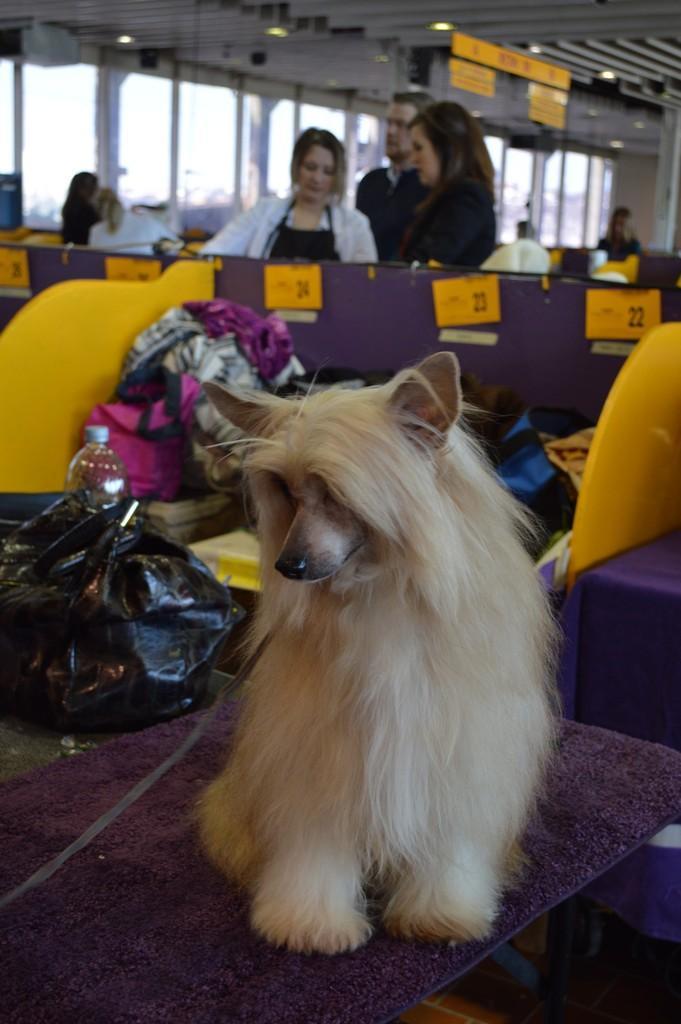Please provide a concise description of this image. In this picture I can see a dog, bag and a bottle on the table, there are group of people standing, there are boards, lights and some other objects, and in the background there are glass windows. 